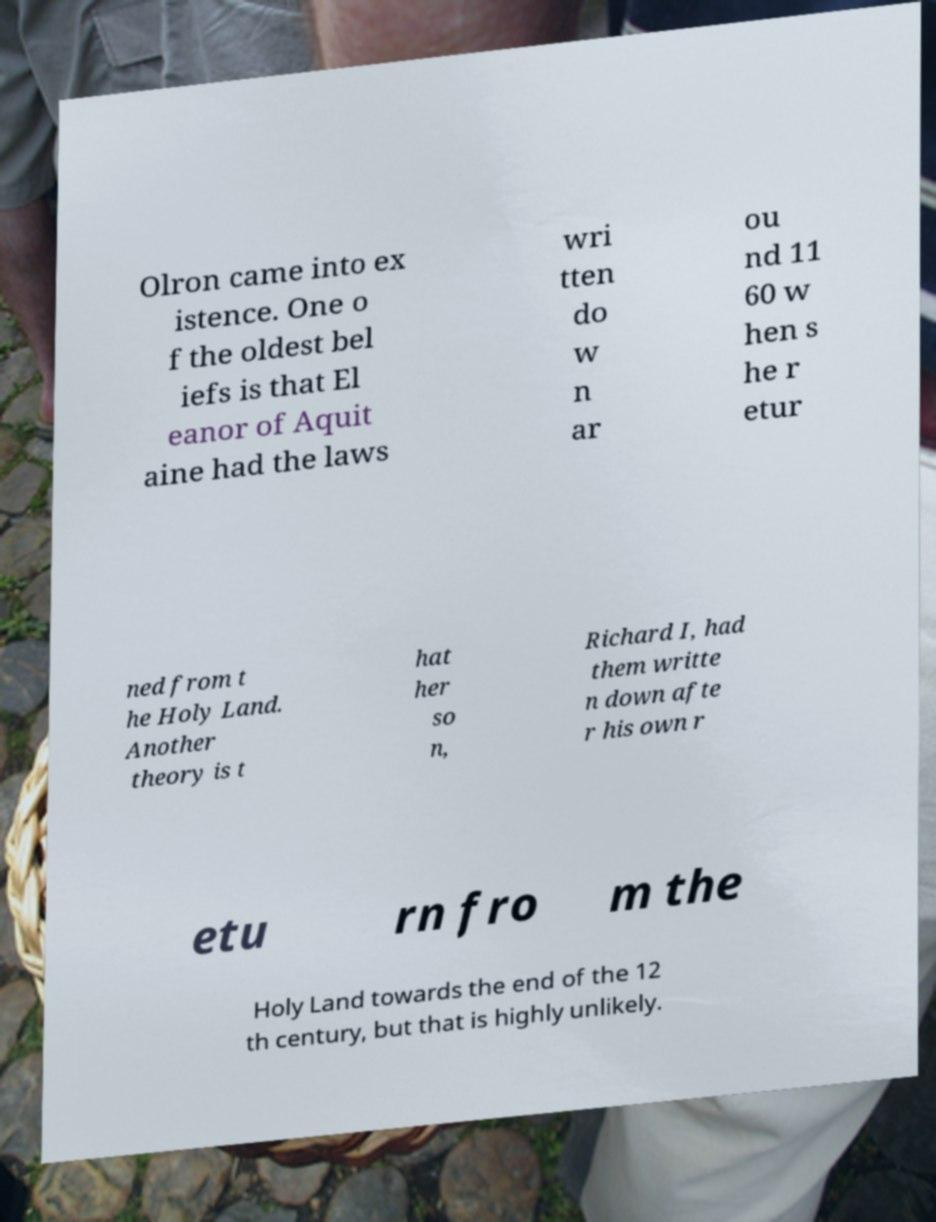I need the written content from this picture converted into text. Can you do that? Olron came into ex istence. One o f the oldest bel iefs is that El eanor of Aquit aine had the laws wri tten do w n ar ou nd 11 60 w hen s he r etur ned from t he Holy Land. Another theory is t hat her so n, Richard I, had them writte n down afte r his own r etu rn fro m the Holy Land towards the end of the 12 th century, but that is highly unlikely. 